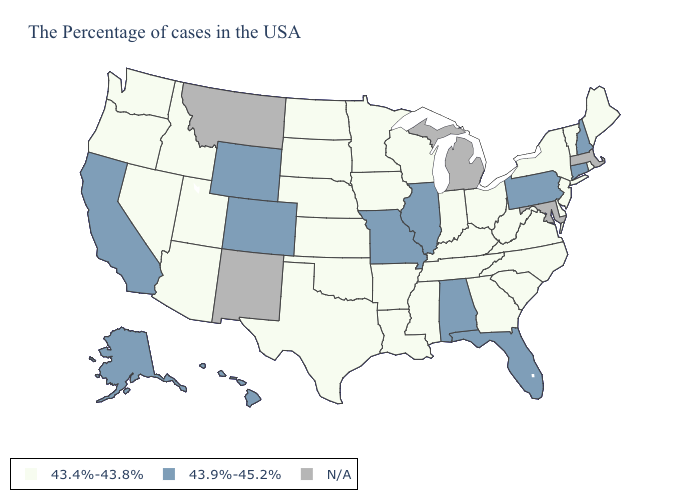Name the states that have a value in the range 43.9%-45.2%?
Keep it brief. New Hampshire, Connecticut, Pennsylvania, Florida, Alabama, Illinois, Missouri, Wyoming, Colorado, California, Alaska, Hawaii. What is the lowest value in the USA?
Quick response, please. 43.4%-43.8%. Name the states that have a value in the range 43.4%-43.8%?
Answer briefly. Maine, Rhode Island, Vermont, New York, New Jersey, Delaware, Virginia, North Carolina, South Carolina, West Virginia, Ohio, Georgia, Kentucky, Indiana, Tennessee, Wisconsin, Mississippi, Louisiana, Arkansas, Minnesota, Iowa, Kansas, Nebraska, Oklahoma, Texas, South Dakota, North Dakota, Utah, Arizona, Idaho, Nevada, Washington, Oregon. Among the states that border Rhode Island , which have the highest value?
Be succinct. Connecticut. What is the highest value in states that border Georgia?
Give a very brief answer. 43.9%-45.2%. Does New Hampshire have the highest value in the USA?
Write a very short answer. Yes. What is the value of New Jersey?
Give a very brief answer. 43.4%-43.8%. Name the states that have a value in the range N/A?
Be succinct. Massachusetts, Maryland, Michigan, New Mexico, Montana. Among the states that border Florida , which have the lowest value?
Keep it brief. Georgia. What is the highest value in the USA?
Keep it brief. 43.9%-45.2%. Does Nebraska have the highest value in the MidWest?
Keep it brief. No. What is the highest value in the USA?
Answer briefly. 43.9%-45.2%. Among the states that border North Dakota , which have the lowest value?
Keep it brief. Minnesota, South Dakota. 